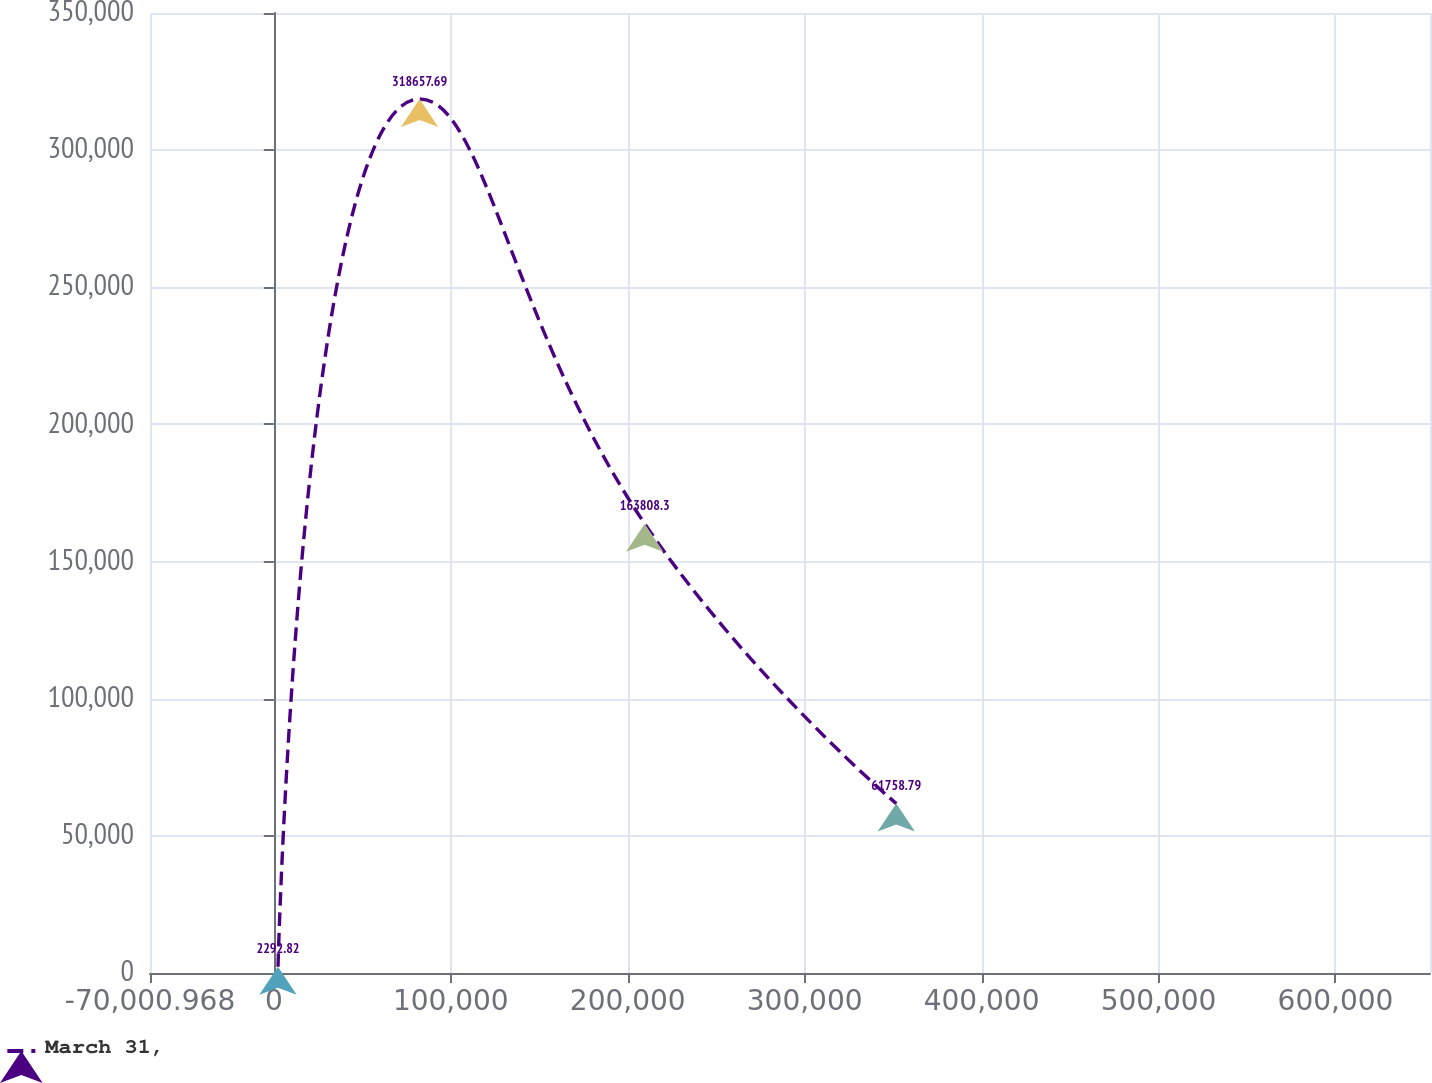<chart> <loc_0><loc_0><loc_500><loc_500><line_chart><ecel><fcel>March 31,<nl><fcel>2342.14<fcel>2292.82<nl><fcel>82366.4<fcel>318658<nl><fcel>209596<fcel>163808<nl><fcel>351778<fcel>61758.8<nl><fcel>725773<fcel>596952<nl></chart> 